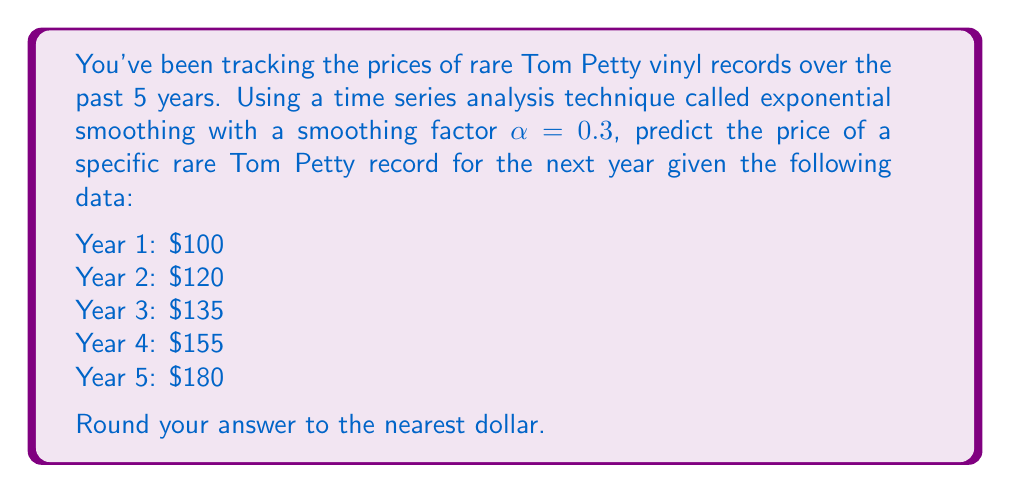Show me your answer to this math problem. To solve this problem, we'll use the exponential smoothing formula:

$$F_{t+1} = \alpha Y_t + (1-\alpha)F_t$$

Where:
$F_{t+1}$ is the forecast for the next period
$\alpha$ is the smoothing factor (0.3 in this case)
$Y_t$ is the actual value at time t
$F_t$ is the forecast for the current period

Let's calculate the forecasts for each year:

Year 1: $F_1 = Y_1 = 100$ (initial forecast is the first actual value)

Year 2: $F_2 = 0.3(100) + 0.7(100) = 100$

Year 3: $F_3 = 0.3(120) + 0.7(100) = 106$

Year 4: $F_4 = 0.3(135) + 0.7(106) = 114.7$

Year 5: $F_5 = 0.3(155) + 0.7(114.7) = 126.79$

Now, to forecast for Year 6:

$F_6 = 0.3(180) + 0.7(126.79) = 142.753$

Rounding to the nearest dollar gives us $143.
Answer: $143 